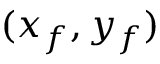<formula> <loc_0><loc_0><loc_500><loc_500>( x _ { f } , y _ { f } )</formula> 